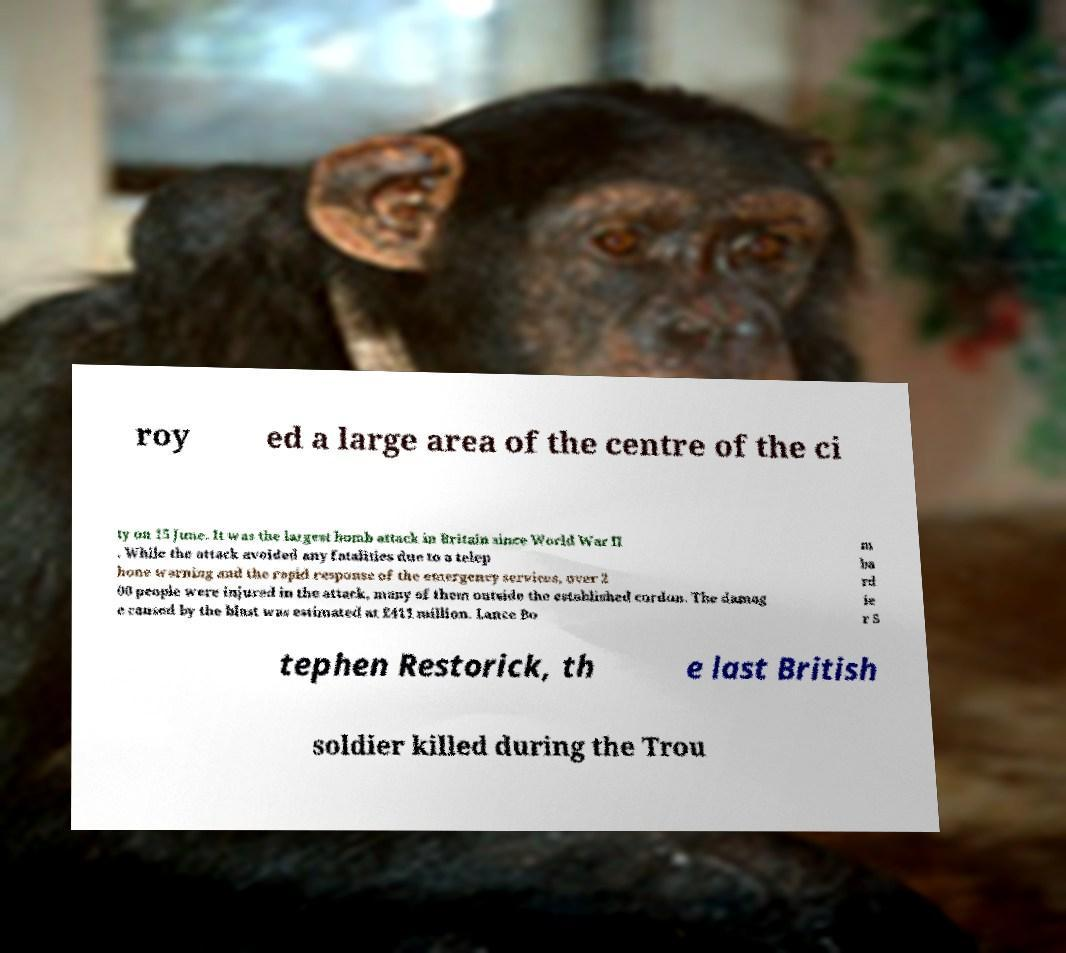Could you assist in decoding the text presented in this image and type it out clearly? roy ed a large area of the centre of the ci ty on 15 June. It was the largest bomb attack in Britain since World War II . While the attack avoided any fatalities due to a telep hone warning and the rapid response of the emergency services, over 2 00 people were injured in the attack, many of them outside the established cordon. The damag e caused by the blast was estimated at £411 million. Lance Bo m ba rd ie r S tephen Restorick, th e last British soldier killed during the Trou 